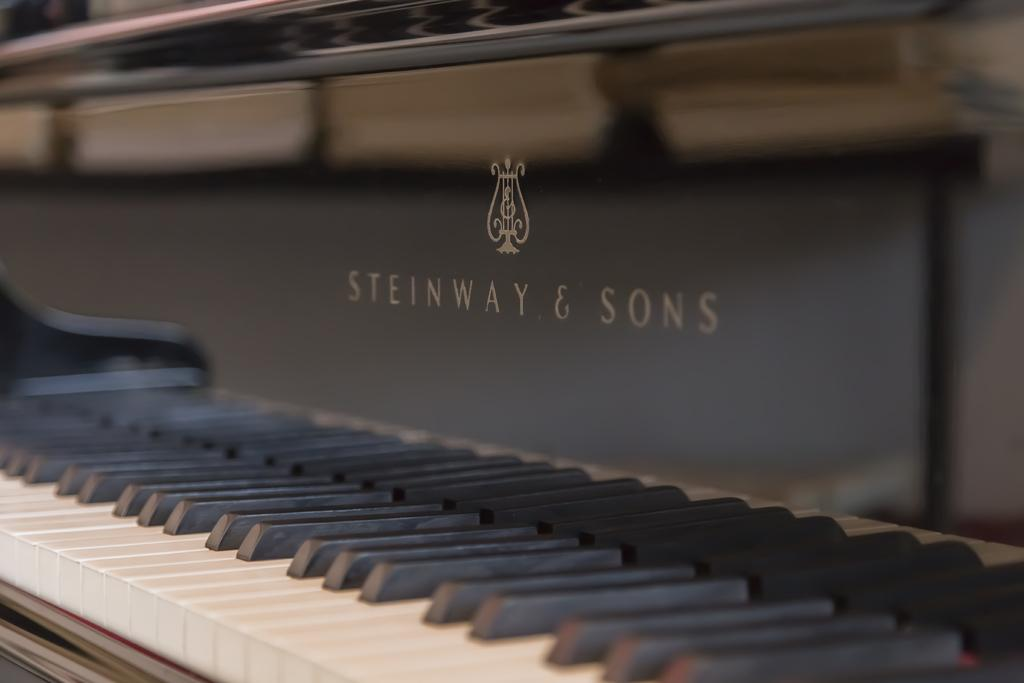What type of musical instrument is in the image? There is a piano in the image. Can you identify the brand of the piano? Yes, the words "Steinway and Sons" are visible on the piano. What type of sack is being used to carry the piano in the image? There is no sack present in the image, and the piano is not being carried. 